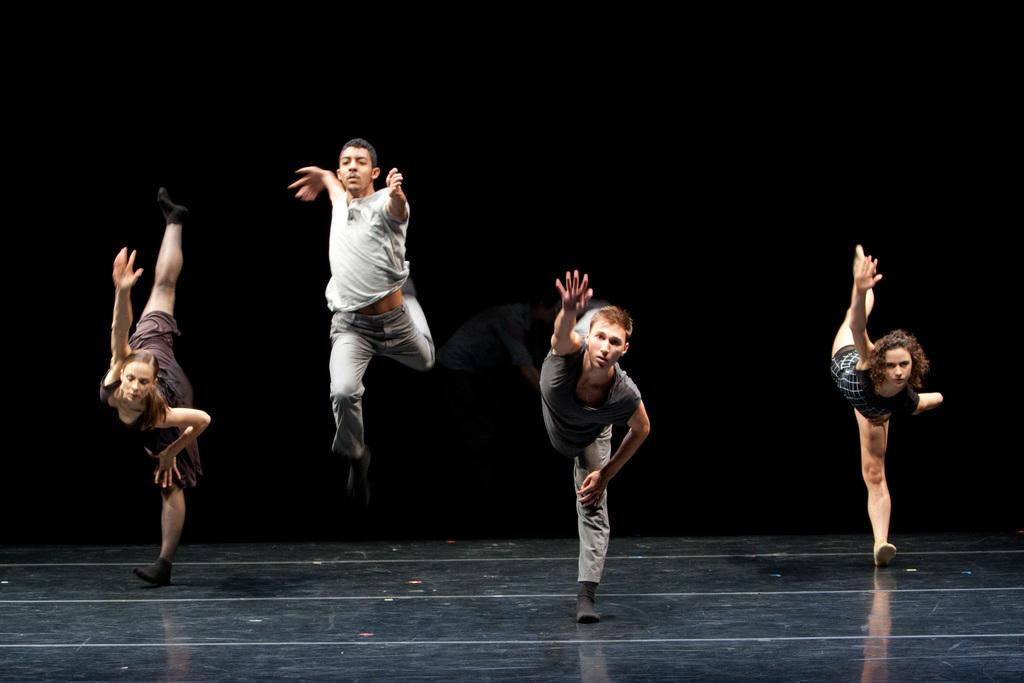How many people are in the image? There are people in the image, but the exact number is not specified. Can you describe the positions of the people in the image? The people have different positions in the image. What color is the background of the image? The background of the image is black. What baby verse is written on the wall in the image? There is no mention of a baby verse or a wall in the image, so this question cannot be answered. 